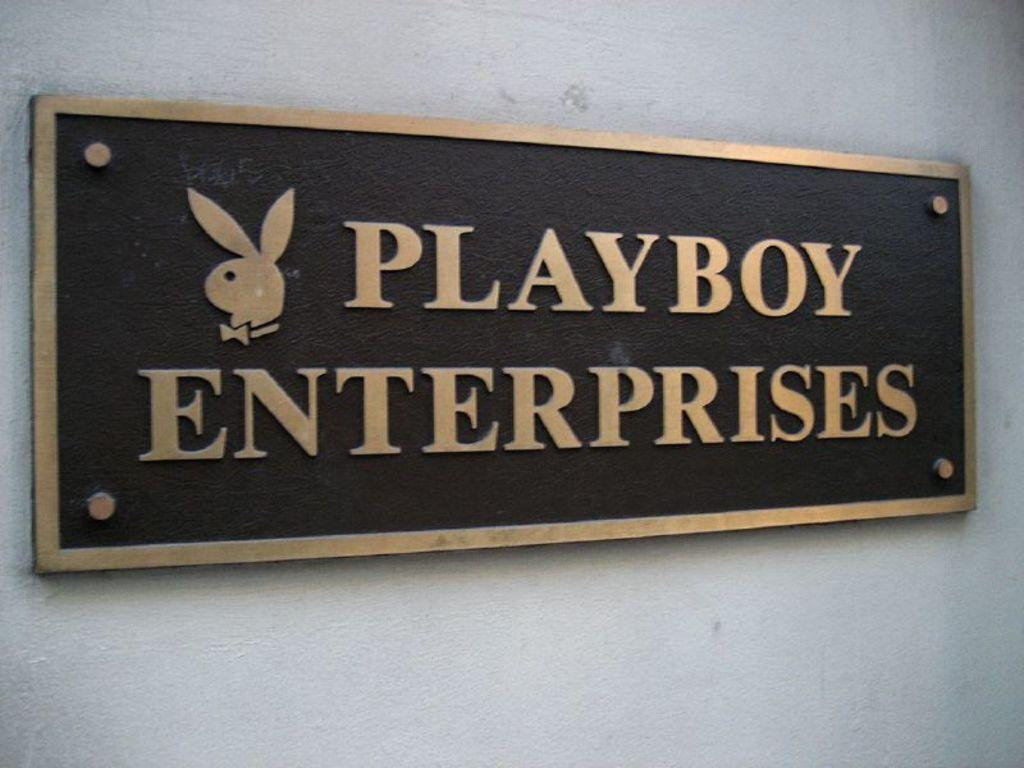What type of object is featured in the image? The object is a name board. How is the name board attached to the wall? The name board is fixed to the wall. What are the screws associated with in the image? The screws are associated with the name board. What is displayed on the name board? There is a logo and letters on the name board. What type of jelly can be seen dripping from the logo on the name board? There is no jelly present in the image, and it is not dripping from the logo on the name board. 